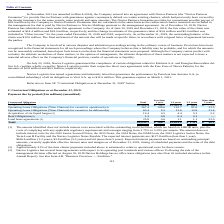Comparing values in Navios Maritime Holdings's report, What percentage of the time charter payments for Operating Lease Obligations (Time Charters) for vessels in operation were estimated to relate to operational costs for the company's vessels? According to the financial document, 41 (percentage). The relevant text states: "(2) Approximately 41% of the time charter payments included above is estimated to relate to operational costs for these..." Also, What was the total long-term debt? According to the financial document, 1,581.8 (in millions). The relevant text states: "Long-term debt (1) $1,581.8 $ 51.7 $1,461.0 $ 69.1 $ —..." Also, What were the total Rent Obligations? According to the financial document, 1.3 (in millions). The relevant text states: "Rent Obligations (3) 1.3 0.8 0.4 0.1 —..." Also, can you calculate: What was the difference between the total rent obligations and land lease agreements? Based on the calculation: 25.8-1.3, the result is 24.5 (in millions). This is based on the information: "Rent Obligations (3) 1.3 0.8 0.4 0.1 — Land lease agreements (3) 25.8 0.6 1.1 1.1 23.0..." The key data points involved are: 1.3, 25.8. Also, can you calculate: What was the difference between the total Acquisition of six liquid barges and long-term debt?  Based on the calculation: 1,581.8-12.4, the result is 1569.4 (in millions). This is based on the information: "Acquisition of six liquid barges (5) 12.4 0.5 4.4 5.3 2.2 Long-term debt (1) $1,581.8 $ 51.7 $1,461.0 $ 69.1 $ —..." The key data points involved are: 1,581.8, 12.4. Also, can you calculate: What percentage of total contractual obligations were due less than a year? Based on the calculation: (168.7/2,052.1), the result is 8.22 (percentage). This is based on the information: "Total $2,052.1 $ 168.7 $1,623.2 $ 170.1 $ 90.1 Total $2,052.1 $ 168.7 $1,623.2 $ 170.1 $ 90.1..." The key data points involved are: 168.7, 2,052.1. 